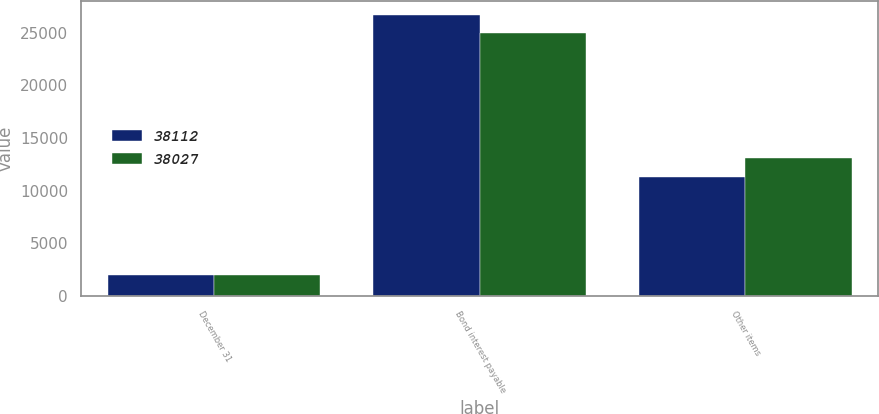Convert chart. <chart><loc_0><loc_0><loc_500><loc_500><stacked_bar_chart><ecel><fcel>December 31<fcel>Bond interest payable<fcel>Other items<nl><fcel>38112<fcel>2008<fcel>26706<fcel>11321<nl><fcel>38027<fcel>2007<fcel>24987<fcel>13125<nl></chart> 